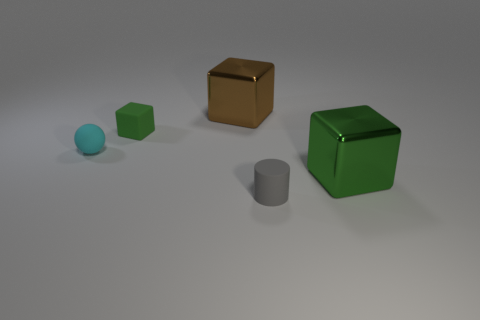Subtract all green blocks. How many blocks are left? 1 Subtract all red spheres. How many green blocks are left? 2 Add 4 big brown shiny blocks. How many objects exist? 9 Subtract all cubes. How many objects are left? 2 Subtract all gray matte cylinders. Subtract all matte cylinders. How many objects are left? 3 Add 2 tiny cylinders. How many tiny cylinders are left? 3 Add 3 yellow matte things. How many yellow matte things exist? 3 Subtract 2 green blocks. How many objects are left? 3 Subtract all red blocks. Subtract all blue spheres. How many blocks are left? 3 